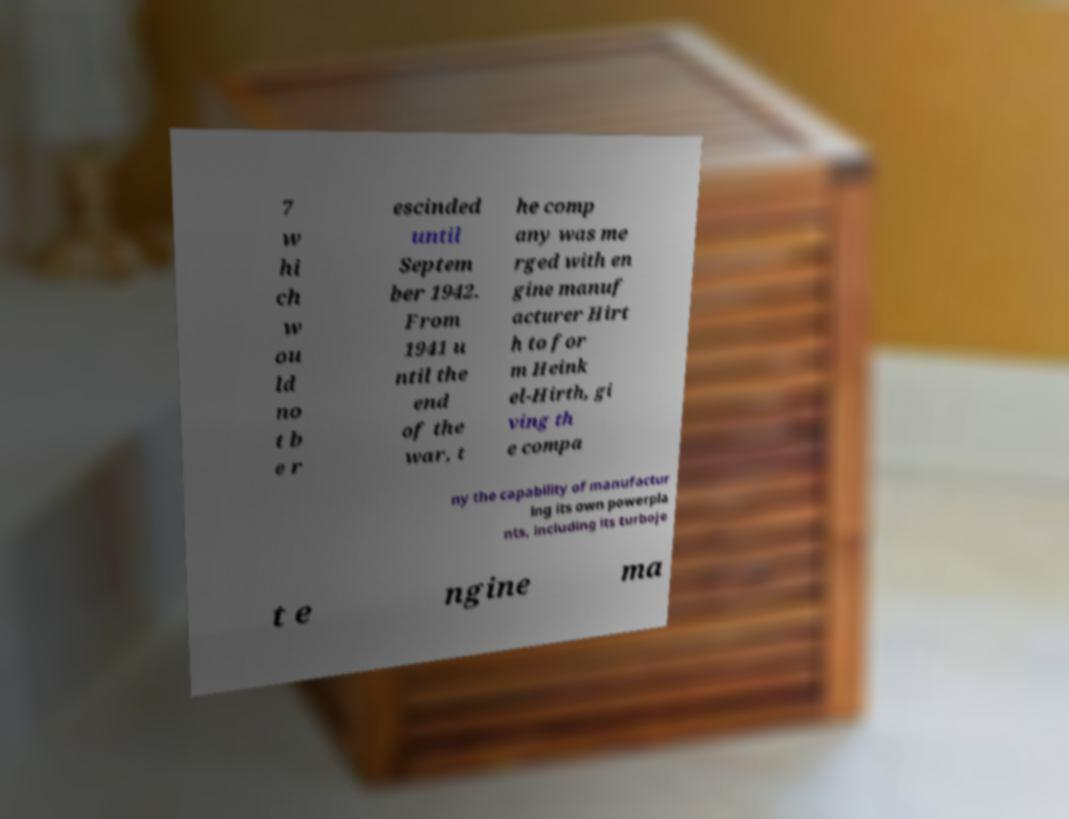There's text embedded in this image that I need extracted. Can you transcribe it verbatim? 7 w hi ch w ou ld no t b e r escinded until Septem ber 1942. From 1941 u ntil the end of the war, t he comp any was me rged with en gine manuf acturer Hirt h to for m Heink el-Hirth, gi ving th e compa ny the capability of manufactur ing its own powerpla nts, including its turboje t e ngine ma 